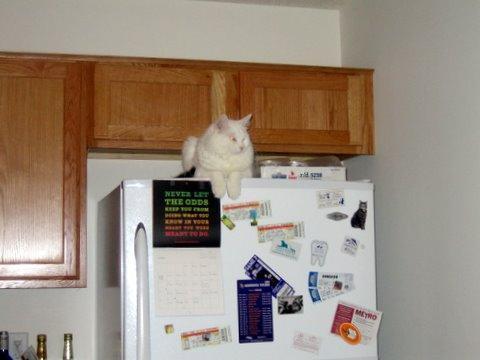How many cats are there?
Give a very brief answer. 1. 